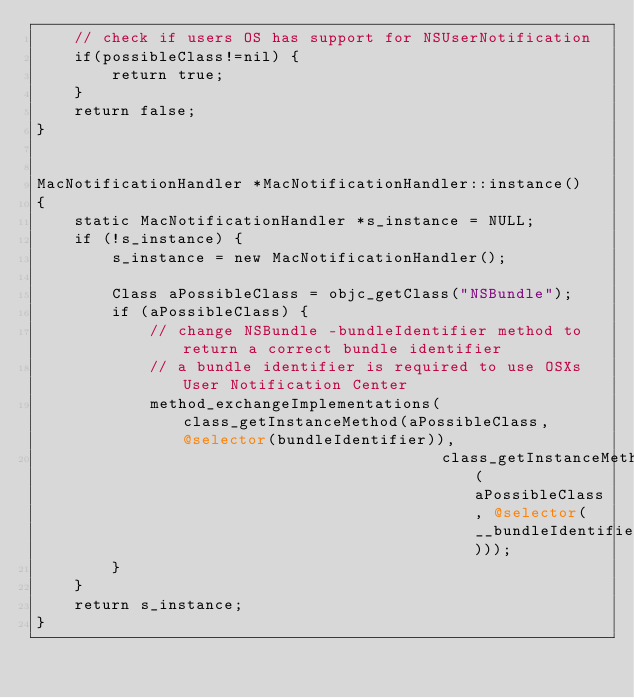<code> <loc_0><loc_0><loc_500><loc_500><_ObjectiveC_>    // check if users OS has support for NSUserNotification
    if(possibleClass!=nil) {
        return true;
    }
    return false;
}


MacNotificationHandler *MacNotificationHandler::instance()
{
    static MacNotificationHandler *s_instance = NULL;
    if (!s_instance) {
        s_instance = new MacNotificationHandler();
        
        Class aPossibleClass = objc_getClass("NSBundle");
        if (aPossibleClass) {
            // change NSBundle -bundleIdentifier method to return a correct bundle identifier
            // a bundle identifier is required to use OSXs User Notification Center
            method_exchangeImplementations(class_getInstanceMethod(aPossibleClass, @selector(bundleIdentifier)),
                                           class_getInstanceMethod(aPossibleClass, @selector(__bundleIdentifier)));
        }
    }
    return s_instance;
}
</code> 